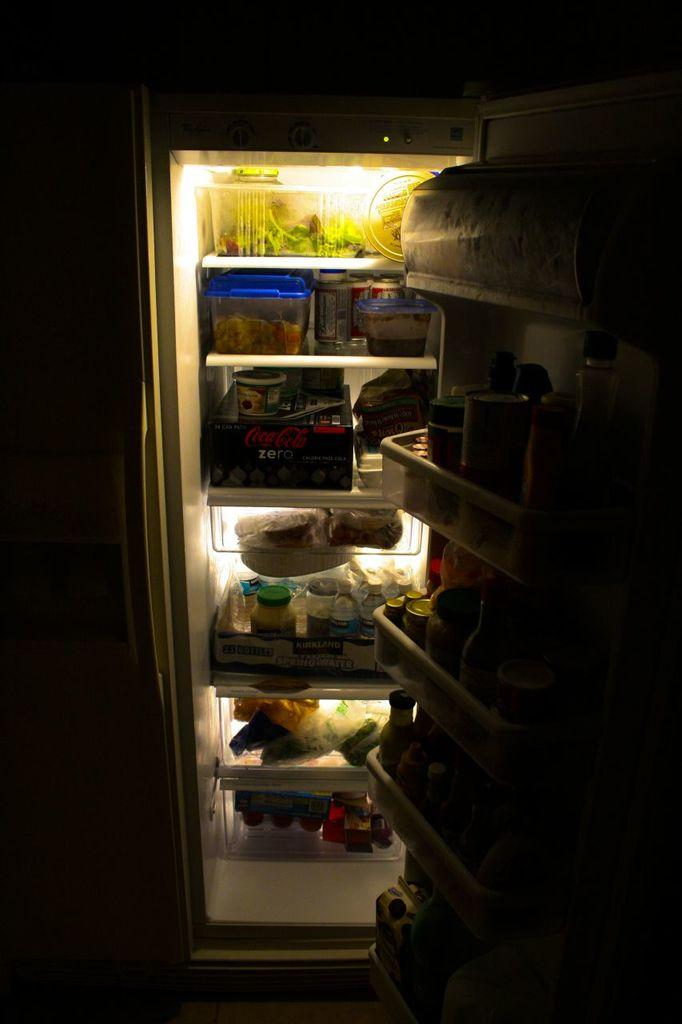<image>
Relay a brief, clear account of the picture shown. an open fridge with a box of coca cola zero in it 